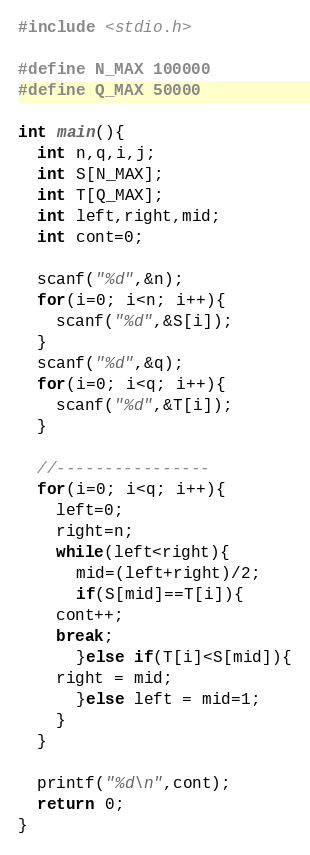<code> <loc_0><loc_0><loc_500><loc_500><_C_>#include <stdio.h>

#define N_MAX 100000
#define Q_MAX 50000

int main(){
  int n,q,i,j;
  int S[N_MAX];
  int T[Q_MAX];
  int left,right,mid;
  int cont=0;

  scanf("%d",&n);
  for(i=0; i<n; i++){
    scanf("%d",&S[i]);
  }
  scanf("%d",&q);
  for(i=0; i<q; i++){
    scanf("%d",&T[i]);
  }

  //----------------
  for(i=0; i<q; i++){
    left=0;
    right=n;
    while(left<right){
      mid=(left+right)/2;
      if(S[mid]==T[i]){
	cont++;
	break;
      }else if(T[i]<S[mid]){
	right = mid;
      }else left = mid=1;
    }
  }

  printf("%d\n",cont);
  return 0;
}

</code> 